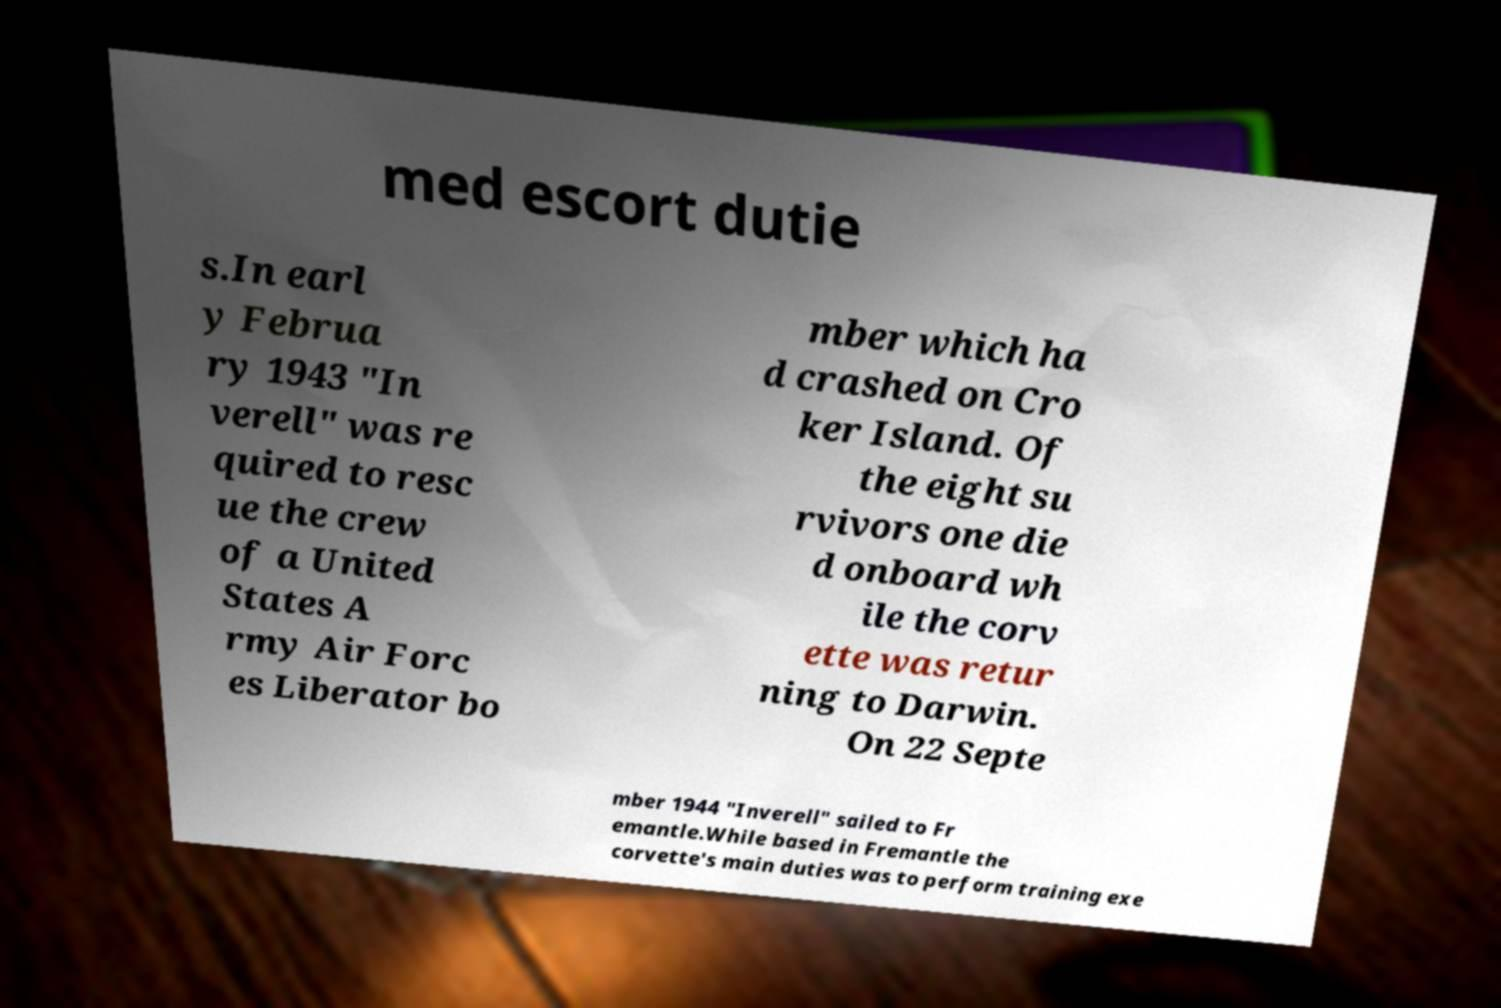Can you read and provide the text displayed in the image?This photo seems to have some interesting text. Can you extract and type it out for me? med escort dutie s.In earl y Februa ry 1943 "In verell" was re quired to resc ue the crew of a United States A rmy Air Forc es Liberator bo mber which ha d crashed on Cro ker Island. Of the eight su rvivors one die d onboard wh ile the corv ette was retur ning to Darwin. On 22 Septe mber 1944 "Inverell" sailed to Fr emantle.While based in Fremantle the corvette's main duties was to perform training exe 